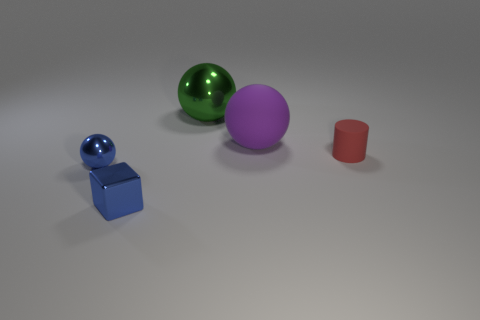Add 1 purple matte things. How many objects exist? 6 Subtract all spheres. How many objects are left? 2 Add 4 tiny red rubber things. How many tiny red rubber things are left? 5 Add 1 small spheres. How many small spheres exist? 2 Subtract 0 green blocks. How many objects are left? 5 Subtract all cylinders. Subtract all tiny objects. How many objects are left? 1 